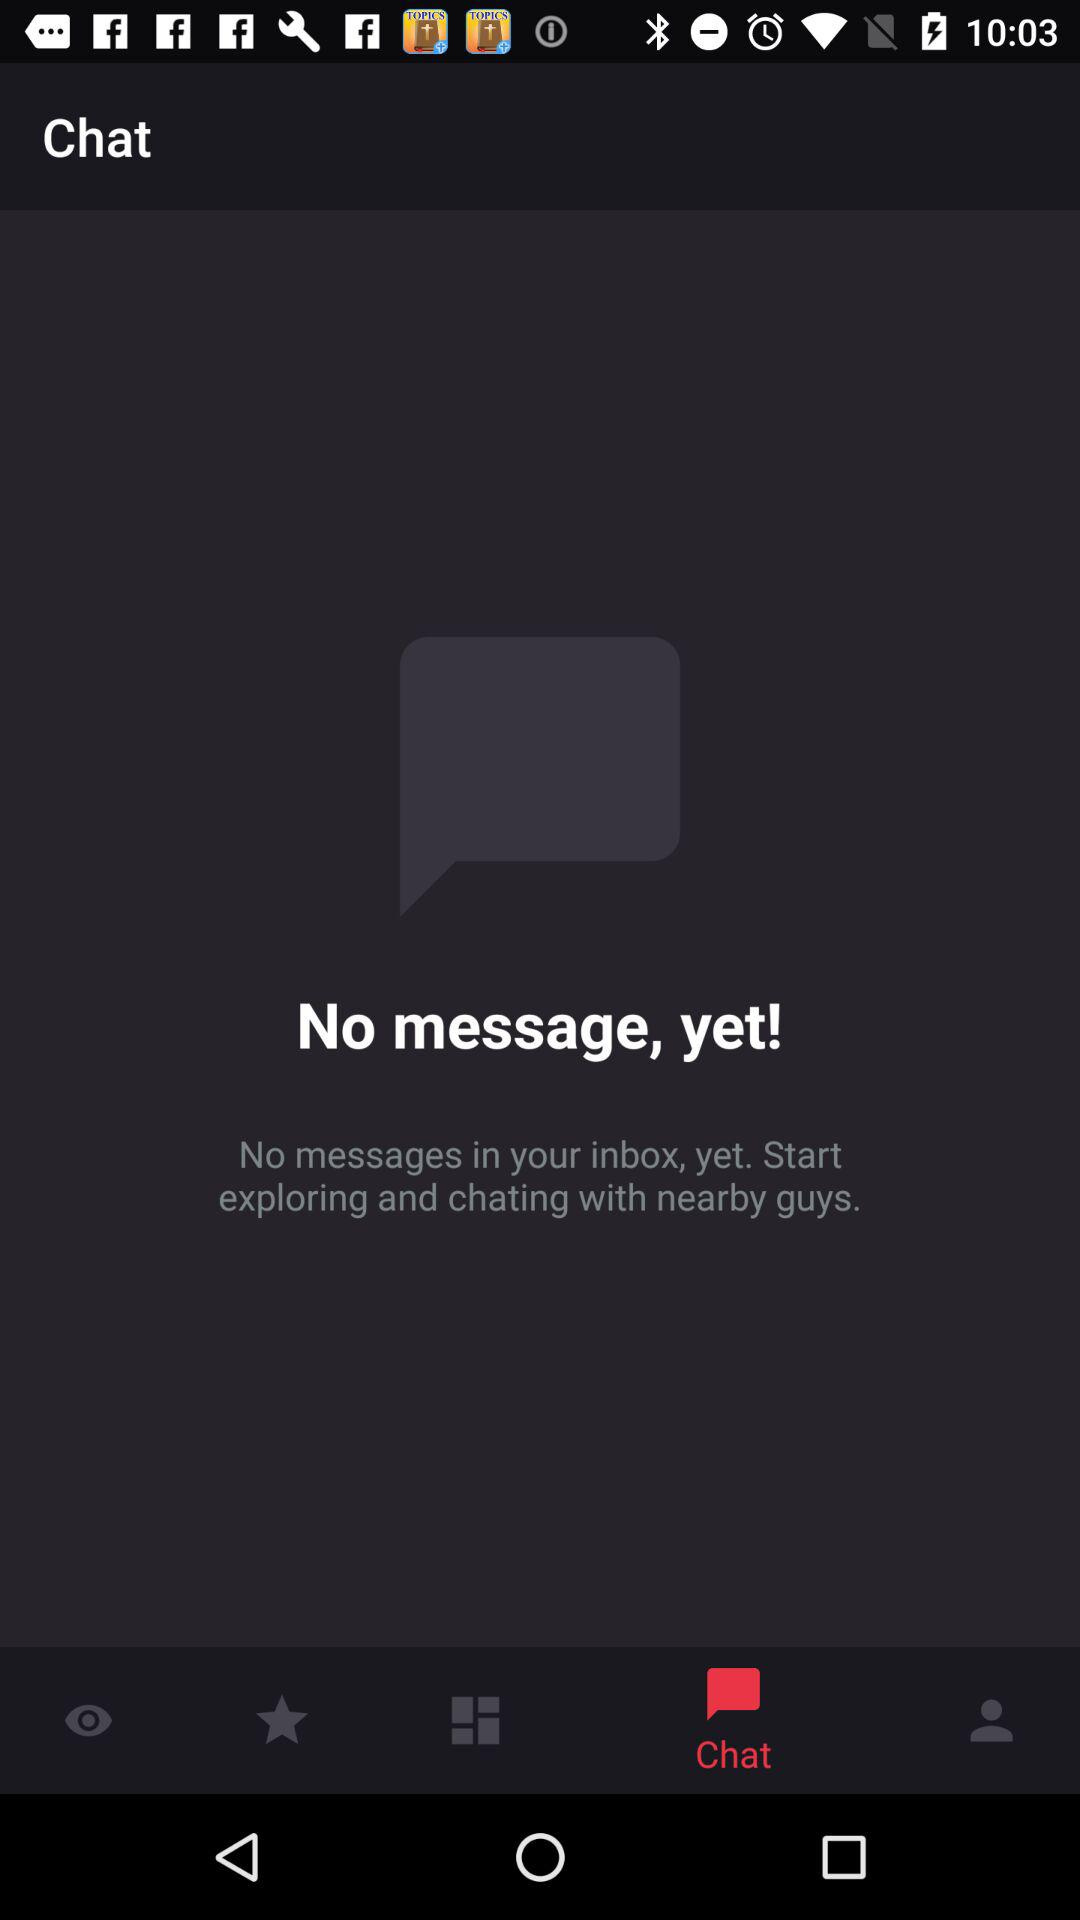How many messages are in the inbox?
Answer the question using a single word or phrase. 0 